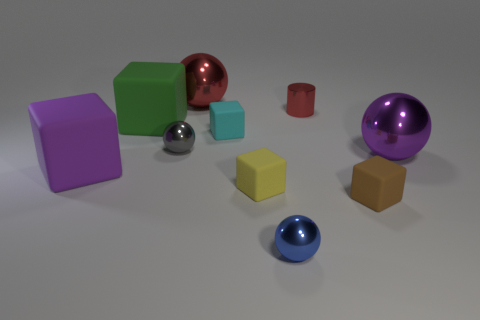Subtract all blue spheres. How many spheres are left? 3 Subtract all gray balls. How many balls are left? 3 Subtract 1 blocks. How many blocks are left? 4 Add 4 big rubber cubes. How many big rubber cubes are left? 6 Add 9 green matte things. How many green matte things exist? 10 Subtract 1 green cubes. How many objects are left? 9 Subtract all cylinders. How many objects are left? 9 Subtract all purple balls. Subtract all yellow cylinders. How many balls are left? 3 Subtract all tiny cyan matte blocks. Subtract all purple balls. How many objects are left? 8 